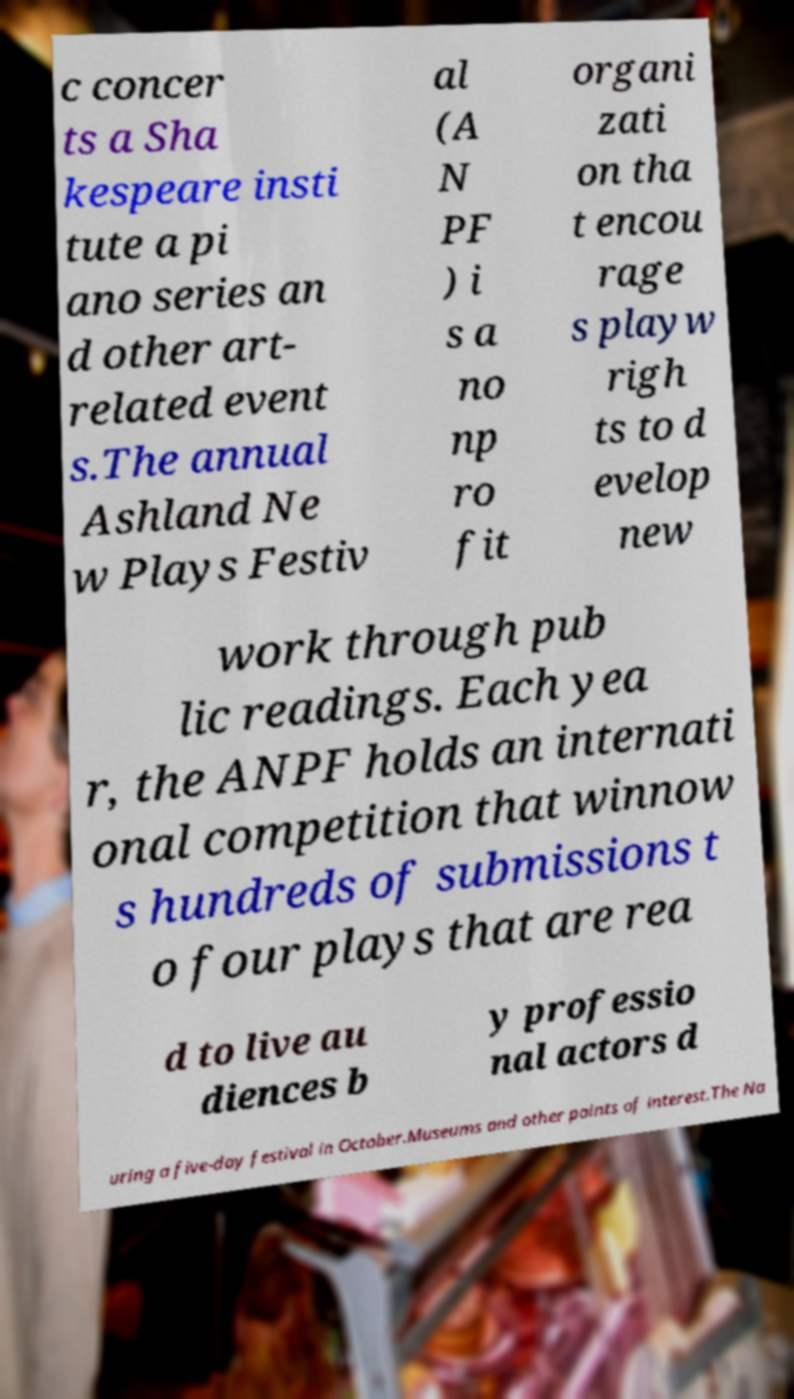What messages or text are displayed in this image? I need them in a readable, typed format. c concer ts a Sha kespeare insti tute a pi ano series an d other art- related event s.The annual Ashland Ne w Plays Festiv al (A N PF ) i s a no np ro fit organi zati on tha t encou rage s playw righ ts to d evelop new work through pub lic readings. Each yea r, the ANPF holds an internati onal competition that winnow s hundreds of submissions t o four plays that are rea d to live au diences b y professio nal actors d uring a five-day festival in October.Museums and other points of interest.The Na 